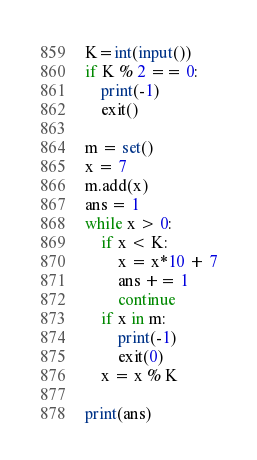Convert code to text. <code><loc_0><loc_0><loc_500><loc_500><_Python_>K=int(input())
if K % 2 == 0:
    print(-1)
    exit()

m = set()
x = 7
m.add(x)
ans = 1
while x > 0:
    if x < K:
        x = x*10 + 7
        ans += 1
        continue
    if x in m:
        print(-1)
        exit(0)
    x = x % K

print(ans)
</code> 